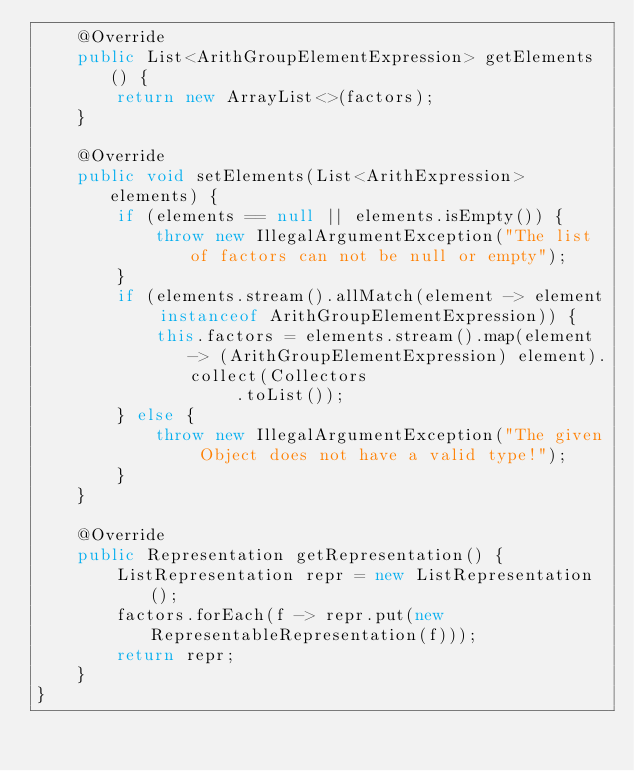<code> <loc_0><loc_0><loc_500><loc_500><_Java_>    @Override
    public List<ArithGroupElementExpression> getElements() {
        return new ArrayList<>(factors);
    }

    @Override
    public void setElements(List<ArithExpression> elements) {
        if (elements == null || elements.isEmpty()) {
            throw new IllegalArgumentException("The list of factors can not be null or empty");
        }
        if (elements.stream().allMatch(element -> element instanceof ArithGroupElementExpression)) {
            this.factors = elements.stream().map(element -> (ArithGroupElementExpression) element).collect(Collectors
                    .toList());
        } else {
            throw new IllegalArgumentException("The given Object does not have a valid type!");
        }
    }

    @Override
    public Representation getRepresentation() {
        ListRepresentation repr = new ListRepresentation();
        factors.forEach(f -> repr.put(new RepresentableRepresentation(f)));
        return repr;
    }
}
</code> 